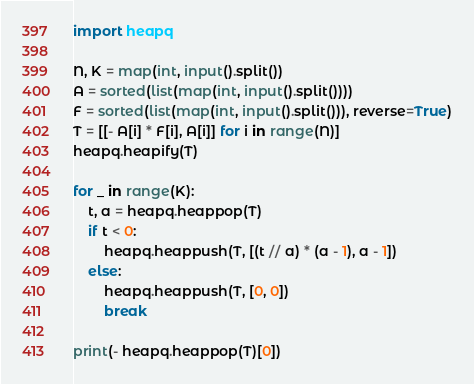<code> <loc_0><loc_0><loc_500><loc_500><_Python_>import heapq

N, K = map(int, input().split())
A = sorted(list(map(int, input().split())))
F = sorted(list(map(int, input().split())), reverse=True)
T = [[- A[i] * F[i], A[i]] for i in range(N)]
heapq.heapify(T)

for _ in range(K):
    t, a = heapq.heappop(T)
    if t < 0:
        heapq.heappush(T, [(t // a) * (a - 1), a - 1])
    else:
        heapq.heappush(T, [0, 0])
        break

print(- heapq.heappop(T)[0])
</code> 